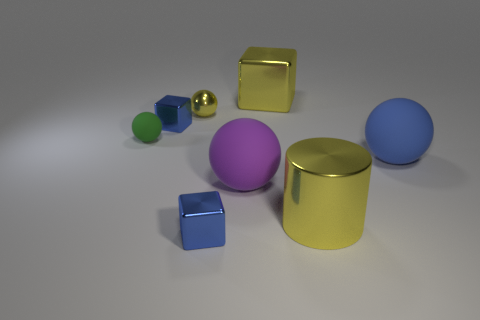There is another yellow thing that is the same shape as the tiny matte thing; what material is it?
Provide a succinct answer. Metal. There is a blue block in front of the small blue block to the left of the metal sphere; what size is it?
Provide a short and direct response. Small. What is the color of the tiny rubber sphere?
Your response must be concise. Green. There is a tiny metallic cube to the left of the tiny yellow thing; what number of small things are in front of it?
Your answer should be compact. 2. Is there a big matte object to the left of the cube behind the tiny yellow metallic object?
Keep it short and to the point. Yes. There is a yellow metallic block; are there any big yellow things in front of it?
Your answer should be very brief. Yes. There is a blue object right of the large yellow metal cylinder; is its shape the same as the tiny yellow object?
Your response must be concise. Yes. How many other tiny green things have the same shape as the green object?
Offer a terse response. 0. Is there a small red thing that has the same material as the yellow ball?
Make the answer very short. No. What is the material of the blue thing to the right of the large yellow shiny thing on the right side of the yellow metal block?
Your answer should be compact. Rubber. 